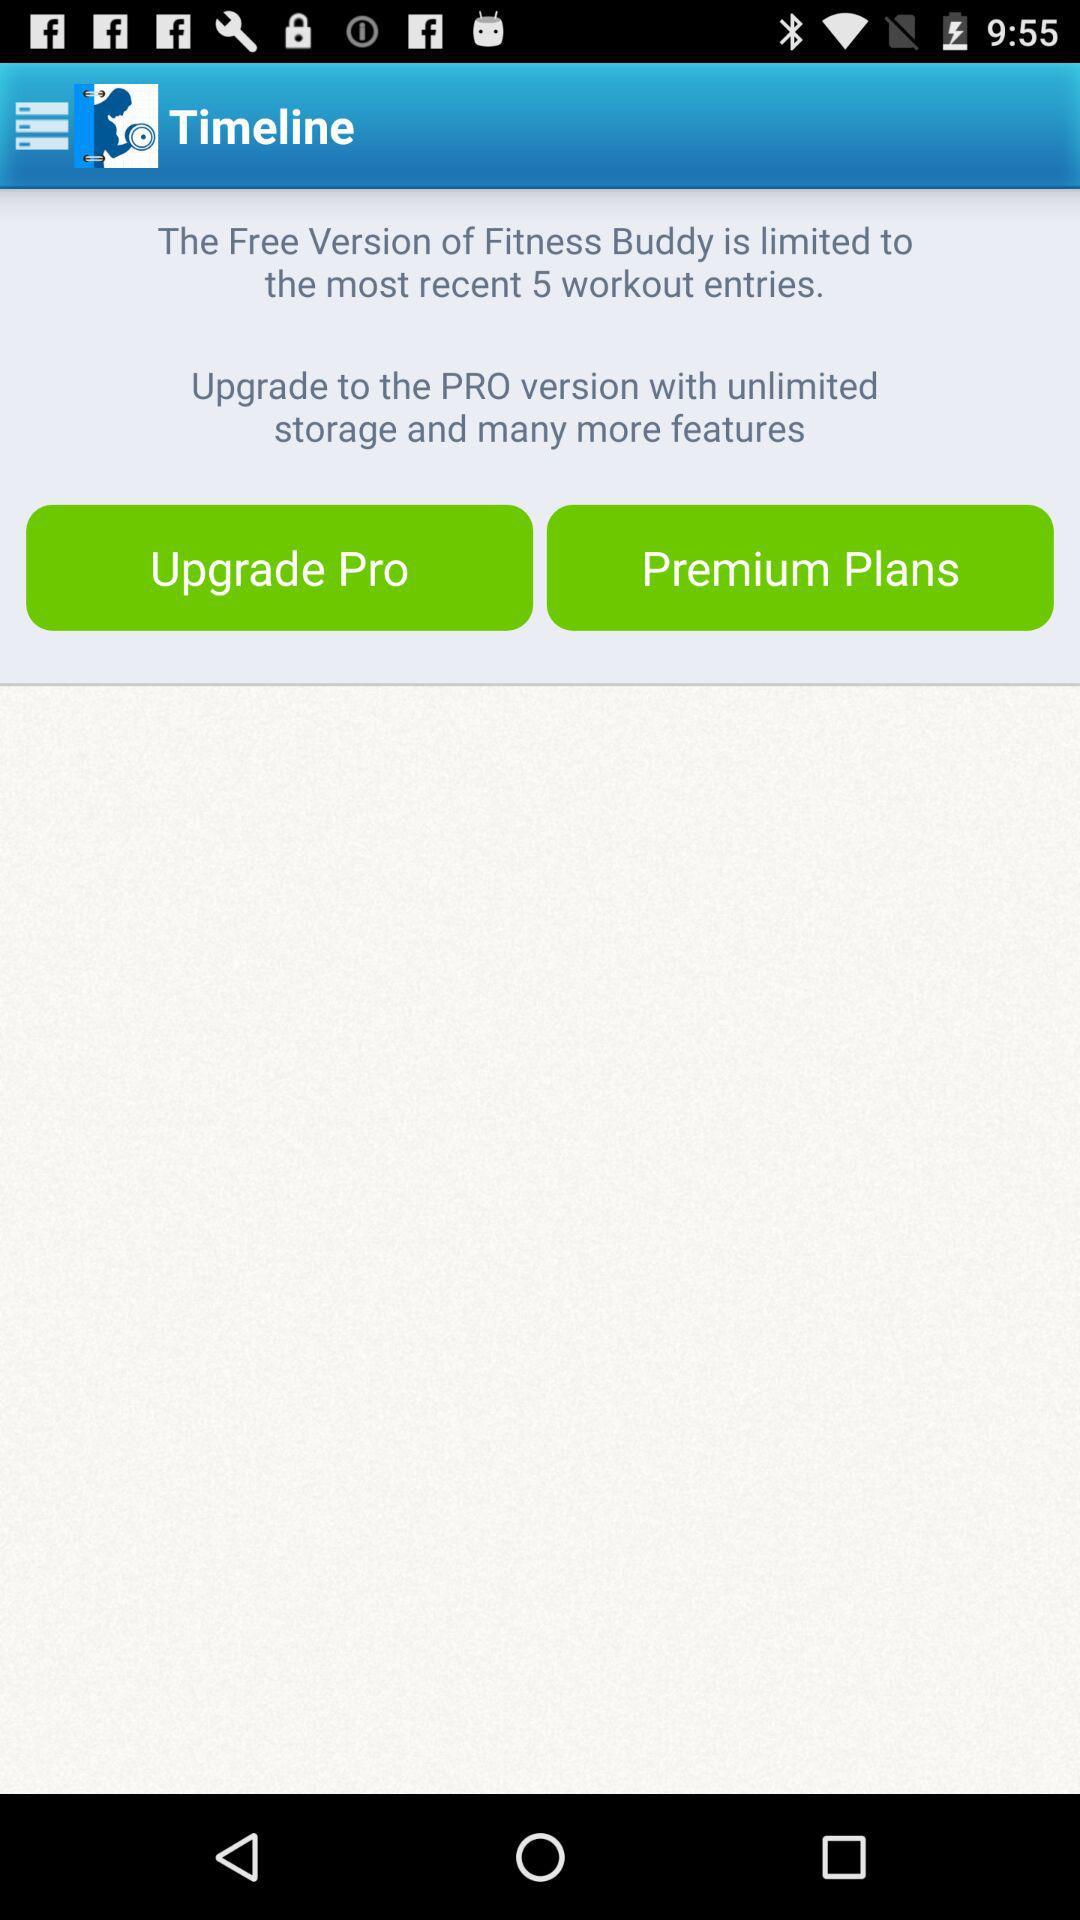How many workout entries can the free version of Fitness Buddy store?
Answer the question using a single word or phrase. 5 